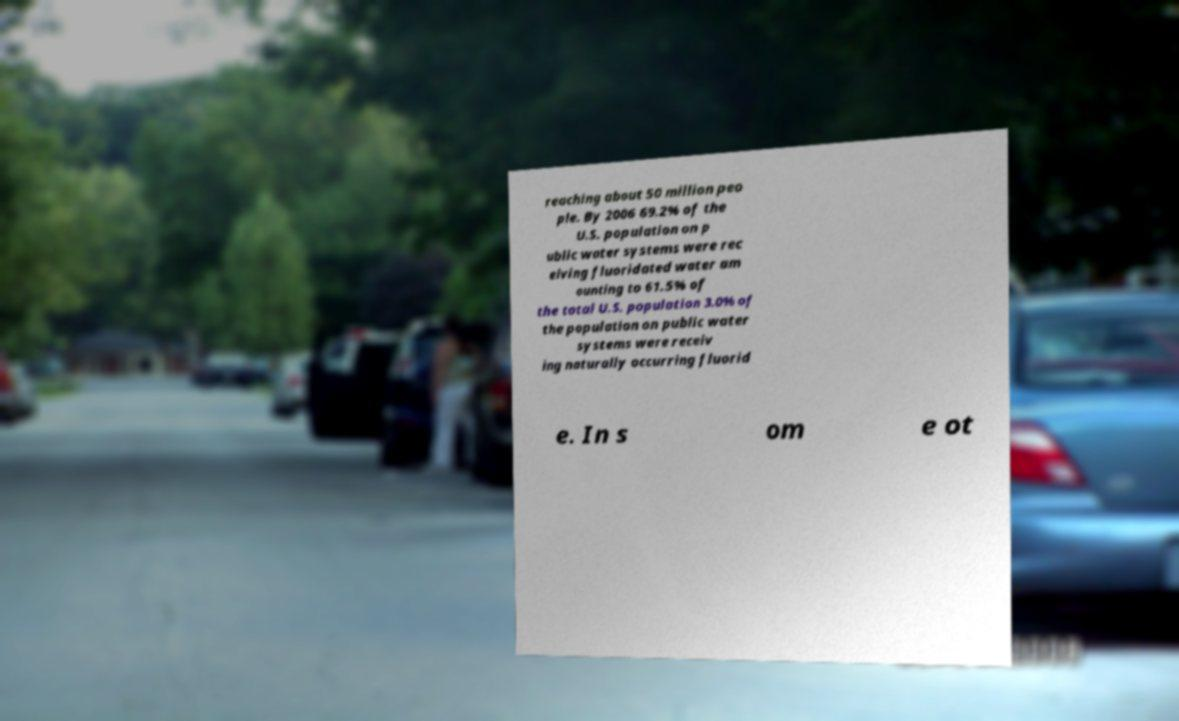Could you extract and type out the text from this image? reaching about 50 million peo ple. By 2006 69.2% of the U.S. population on p ublic water systems were rec eiving fluoridated water am ounting to 61.5% of the total U.S. population 3.0% of the population on public water systems were receiv ing naturally occurring fluorid e. In s om e ot 